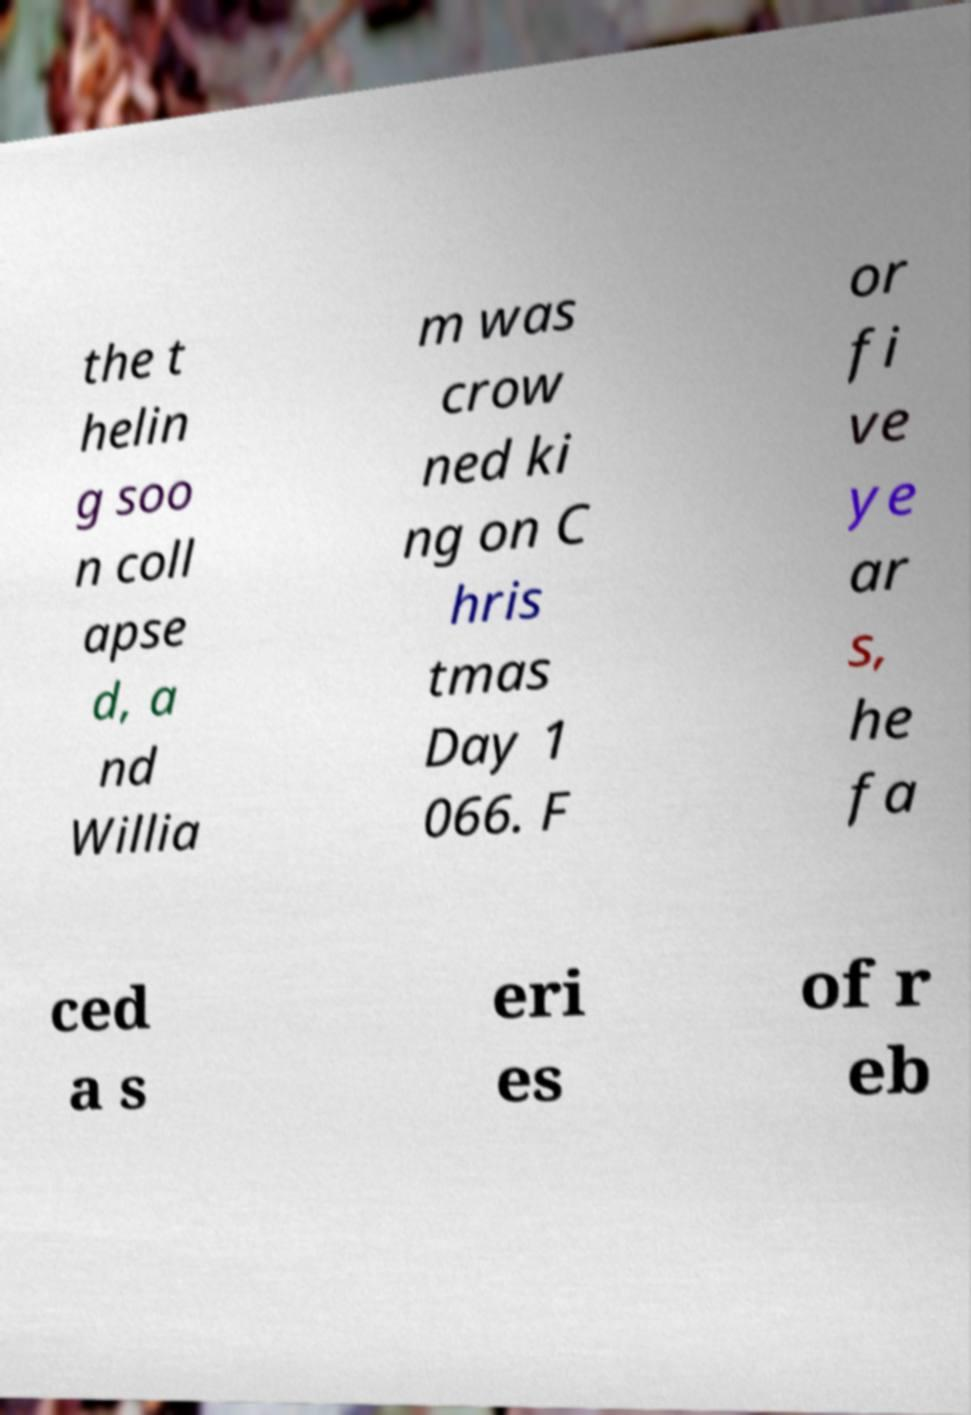Please read and relay the text visible in this image. What does it say? the t helin g soo n coll apse d, a nd Willia m was crow ned ki ng on C hris tmas Day 1 066. F or fi ve ye ar s, he fa ced a s eri es of r eb 